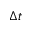Convert formula to latex. <formula><loc_0><loc_0><loc_500><loc_500>\Delta t</formula> 